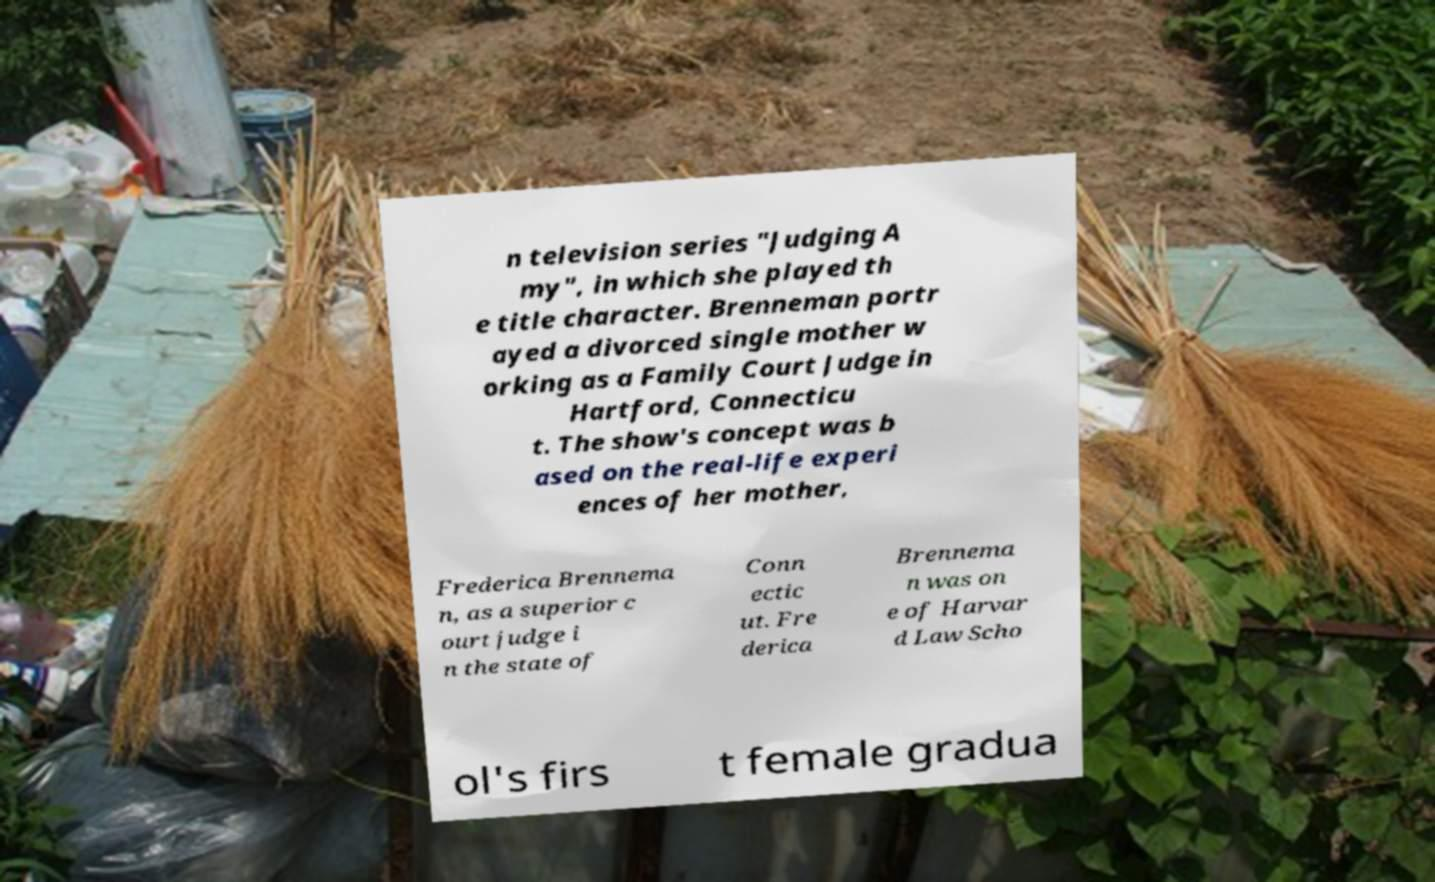Could you extract and type out the text from this image? n television series "Judging A my", in which she played th e title character. Brenneman portr ayed a divorced single mother w orking as a Family Court Judge in Hartford, Connecticu t. The show's concept was b ased on the real-life experi ences of her mother, Frederica Brennema n, as a superior c ourt judge i n the state of Conn ectic ut. Fre derica Brennema n was on e of Harvar d Law Scho ol's firs t female gradua 